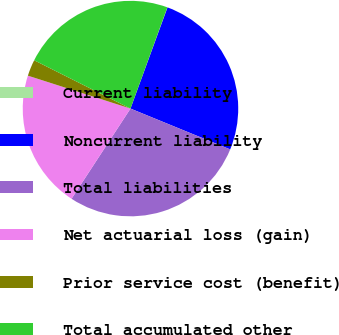Convert chart to OTSL. <chart><loc_0><loc_0><loc_500><loc_500><pie_chart><fcel>Current liability<fcel>Noncurrent liability<fcel>Total liabilities<fcel>Net actuarial loss (gain)<fcel>Prior service cost (benefit)<fcel>Total accumulated other<nl><fcel>0.03%<fcel>25.6%<fcel>28.03%<fcel>20.73%<fcel>2.46%<fcel>23.16%<nl></chart> 